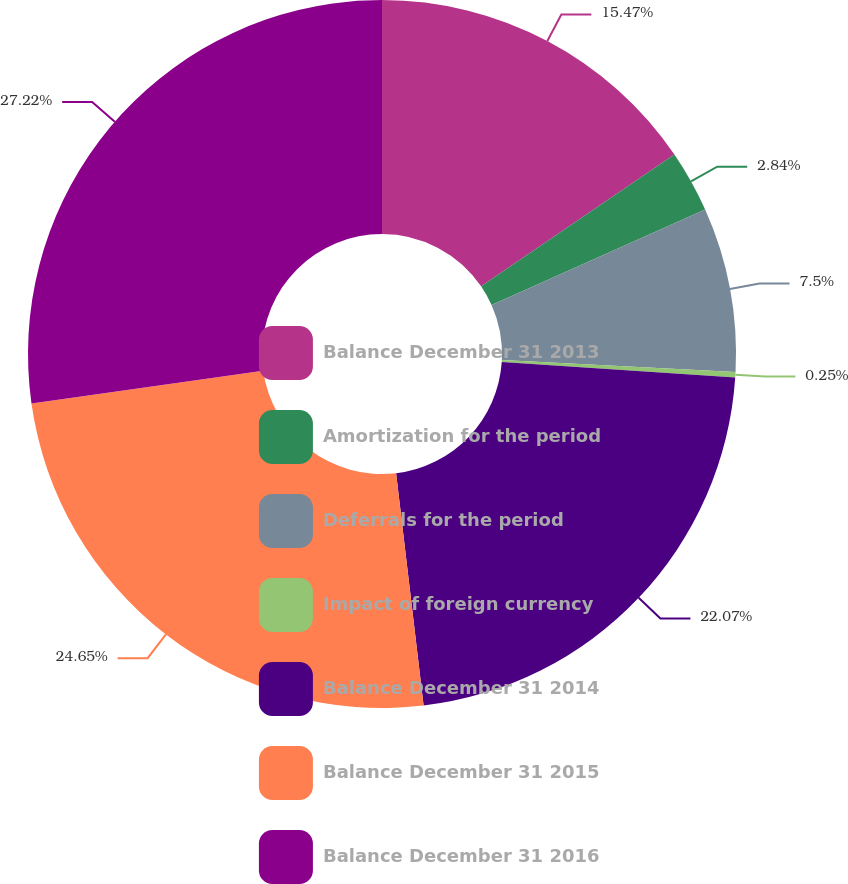<chart> <loc_0><loc_0><loc_500><loc_500><pie_chart><fcel>Balance December 31 2013<fcel>Amortization for the period<fcel>Deferrals for the period<fcel>Impact of foreign currency<fcel>Balance December 31 2014<fcel>Balance December 31 2015<fcel>Balance December 31 2016<nl><fcel>15.47%<fcel>2.84%<fcel>7.5%<fcel>0.25%<fcel>22.07%<fcel>24.65%<fcel>27.23%<nl></chart> 